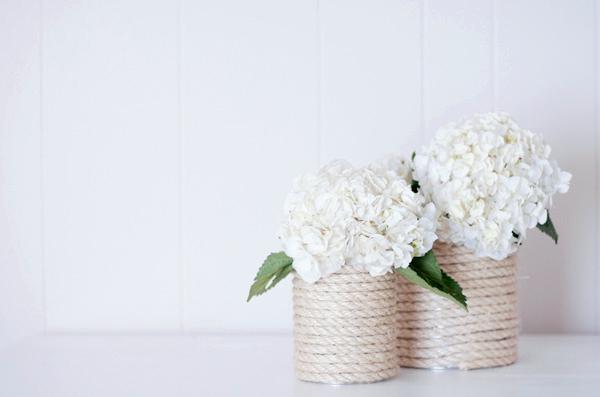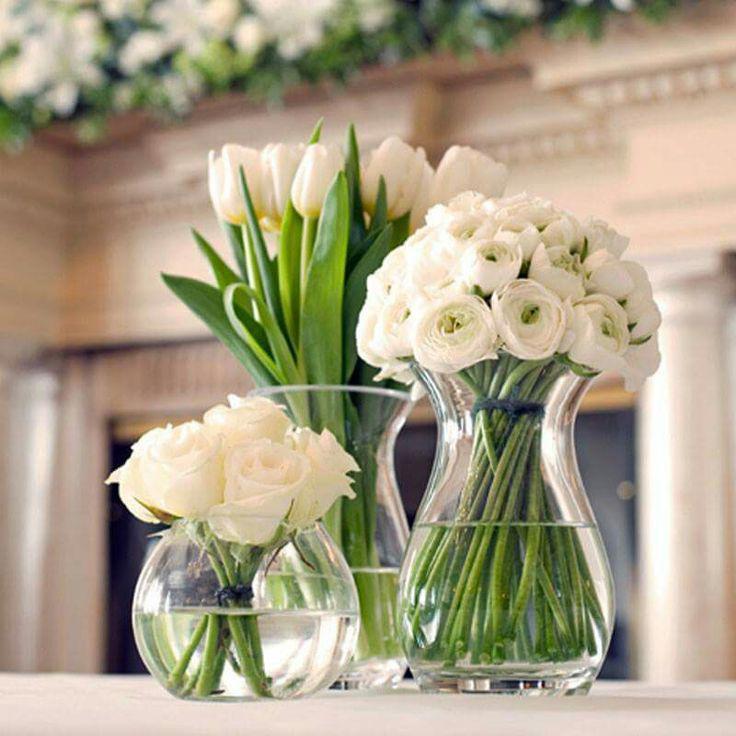The first image is the image on the left, the second image is the image on the right. For the images displayed, is the sentence "There are multiple vases in the right image with the centre one the highest." factually correct? Answer yes or no. Yes. 